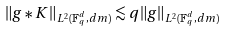<formula> <loc_0><loc_0><loc_500><loc_500>\| g \ast K \| _ { L ^ { 2 } ( { \mathbb { F } _ { q } ^ { d } } , d m ) } \lesssim q \| g \| _ { L ^ { 2 } ( { \mathbb { F } _ { q } ^ { d } } , d m ) }</formula> 